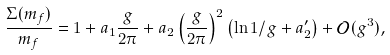<formula> <loc_0><loc_0><loc_500><loc_500>\frac { \Sigma ( m _ { f } ) } { m _ { f } } = 1 + a _ { 1 } \frac { g } { 2 \pi } + a _ { 2 } \left ( \frac { g } { 2 \pi } \right ) ^ { 2 } \left ( \ln 1 / g + a _ { 2 } ^ { \prime } \right ) + \mathcal { O } ( g ^ { 3 } ) ,</formula> 